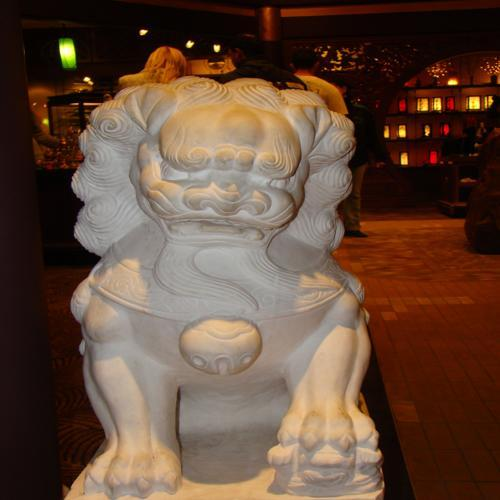Where might you typically find such statues? Statues like the one in the image are typically found at the entrances of temples, imperial palaces, government offices, and sometimes homes of the affluent and influential individuals in Chinese society. They are meant to guard the premises from harmful spiritual influences and malicious beings. 